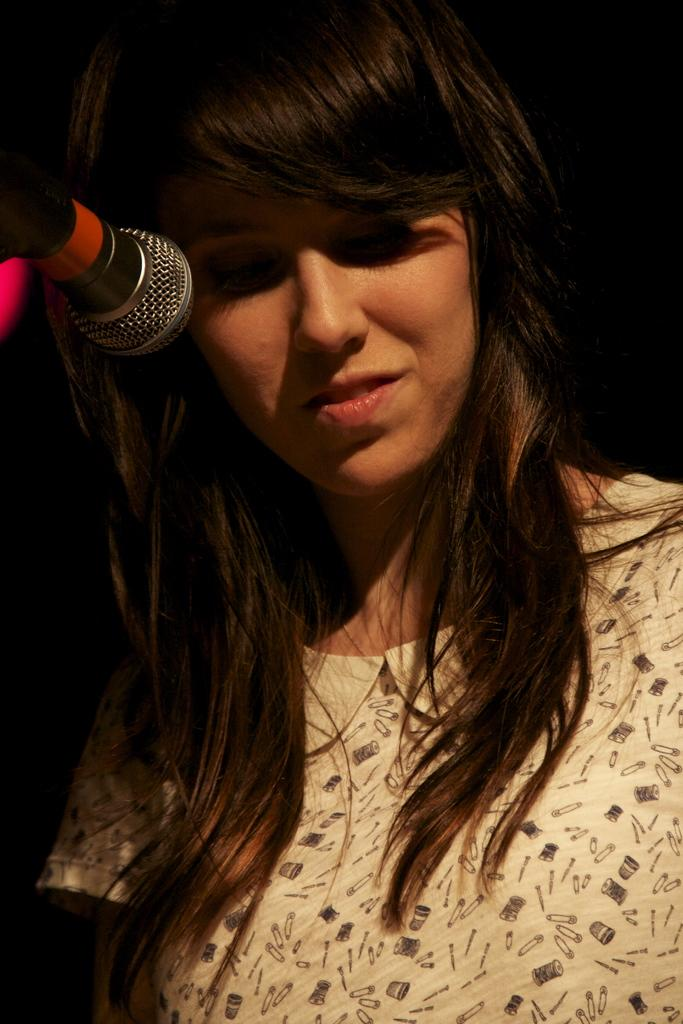Who is the main subject in the image? There is a lady in the image. What is the lady wearing? The lady is wearing a white dress. What is the lady doing in the image? The lady is standing in front of a mic. What type of wax can be seen dripping from the lady's dress in the image? There is no wax present in the image, nor is there any wax dripping from the lady's dress. 